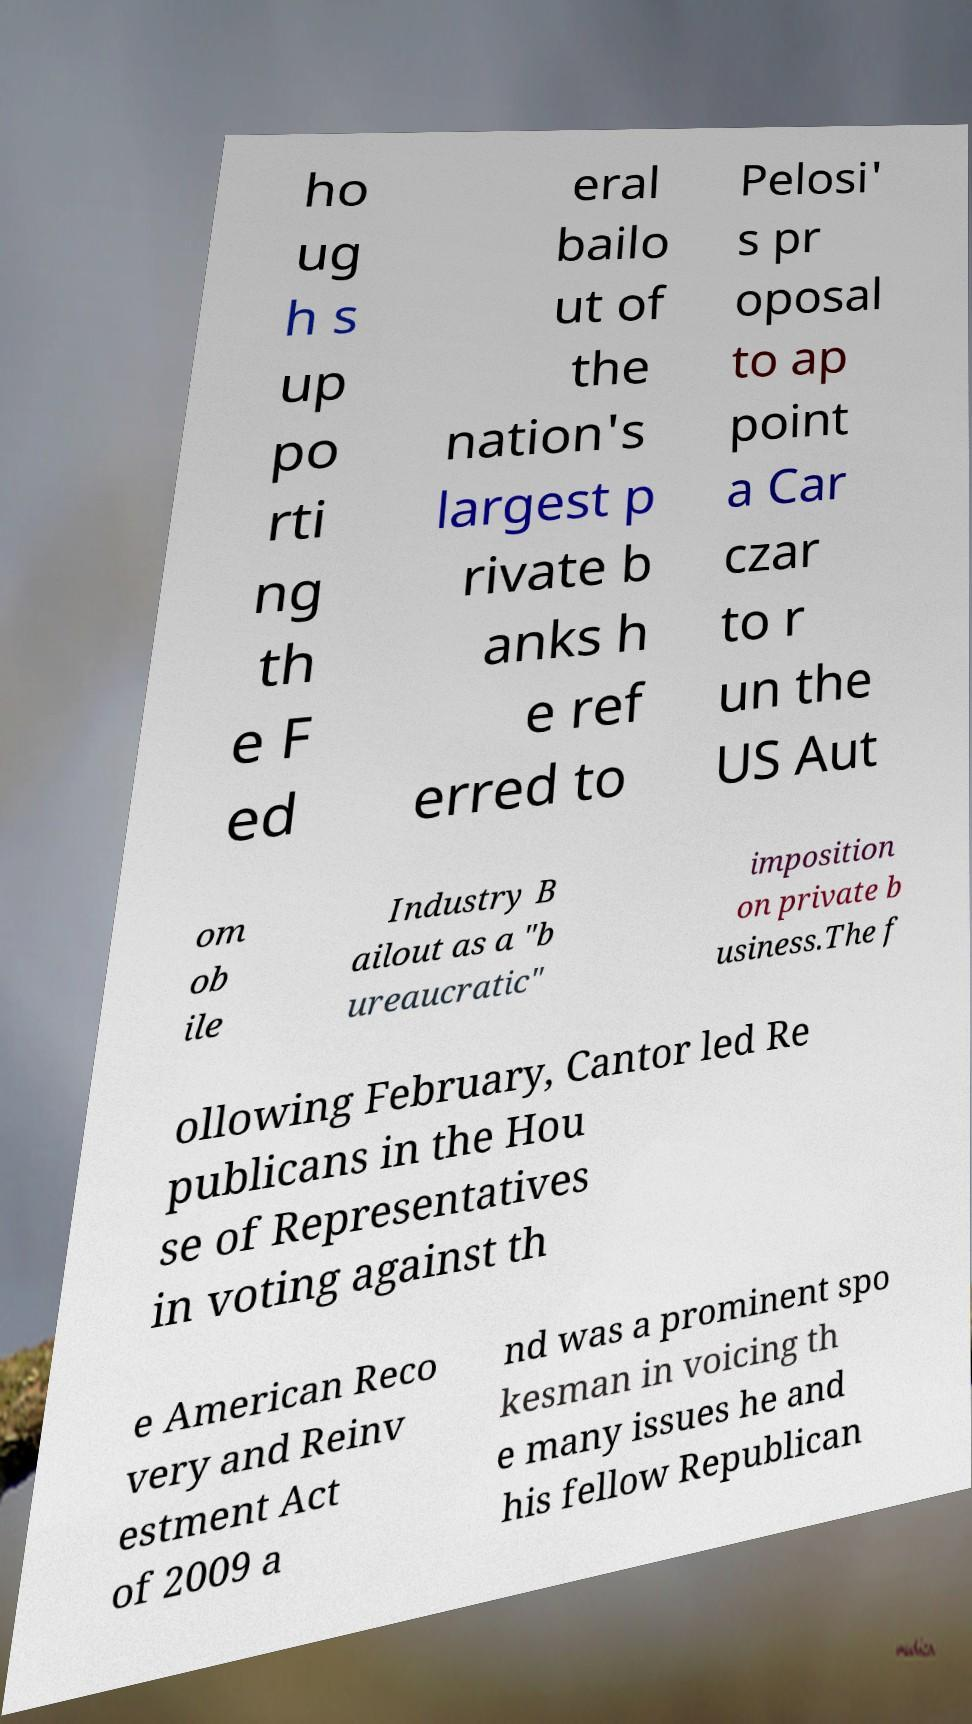Could you extract and type out the text from this image? ho ug h s up po rti ng th e F ed eral bailo ut of the nation's largest p rivate b anks h e ref erred to Pelosi' s pr oposal to ap point a Car czar to r un the US Aut om ob ile Industry B ailout as a "b ureaucratic" imposition on private b usiness.The f ollowing February, Cantor led Re publicans in the Hou se of Representatives in voting against th e American Reco very and Reinv estment Act of 2009 a nd was a prominent spo kesman in voicing th e many issues he and his fellow Republican 